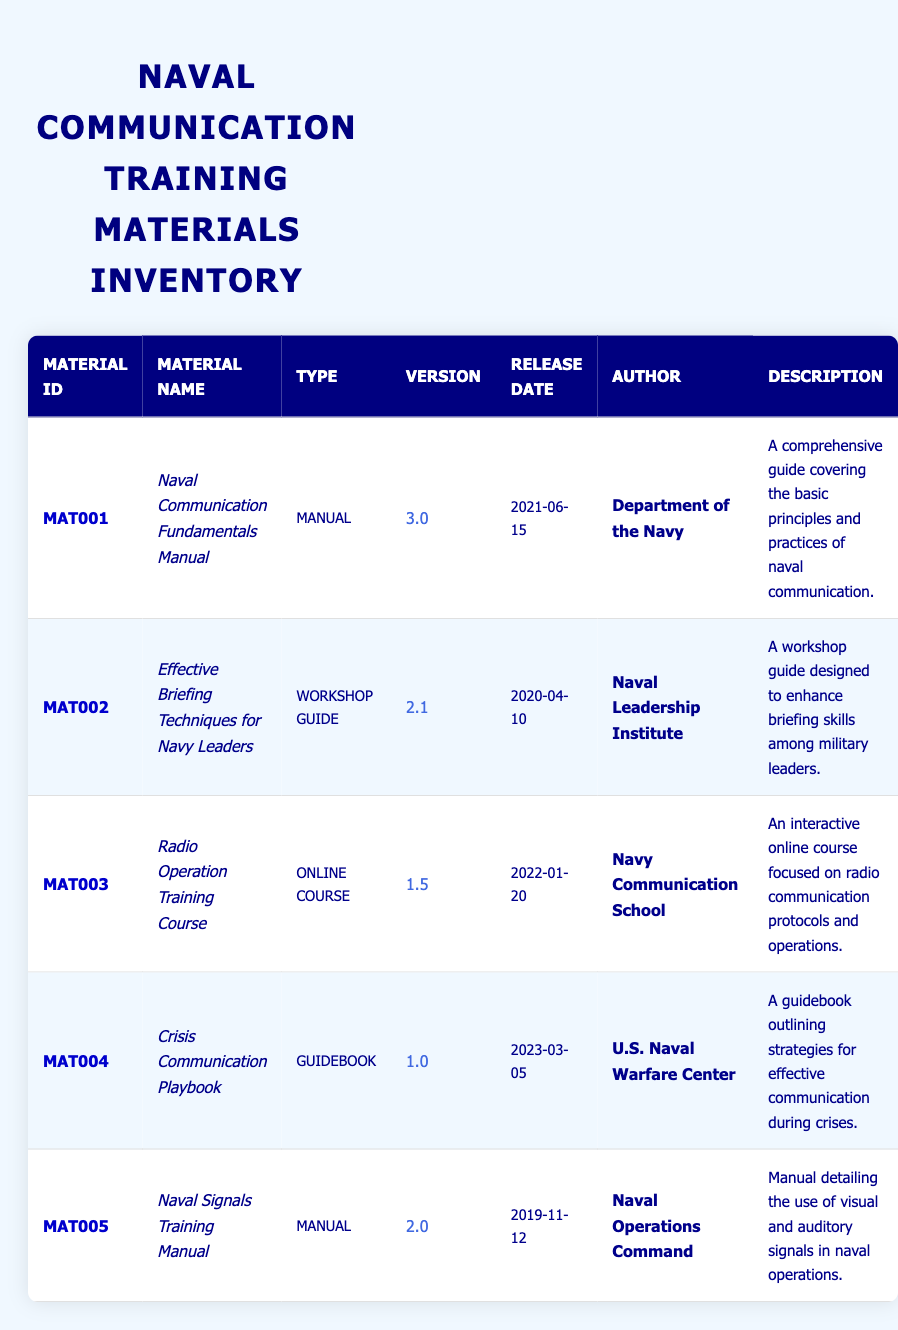What is the title of the manual with material ID MAT001? By looking at the inventory table, we see that for the material ID MAT001, the corresponding material name is "Naval Communication Fundamentals Manual".
Answer: Naval Communication Fundamentals Manual Who is the author of the "Crisis Communication Playbook"? The inventory lists the author of the material titled "Crisis Communication Playbook" as "U.S. Naval Warfare Center".
Answer: U.S. Naval Warfare Center What type of training material was released most recently? Checking the release dates in the table, the "Crisis Communication Playbook" with a release date of "2023-03-05" was released most recently.
Answer: Guidebook Is the version of the "Radio Operation Training Course" greater than 1.0? The version for the "Radio Operation Training Course" is "1.5", which is greater than "1.0". So, the answer is yes.
Answer: Yes How many training materials are authored by the Department of the Navy? In the inventory, there is one entry where the author is listed as "Department of the Navy", specifically for the "Naval Communication Fundamentals Manual".
Answer: 1 What is the difference in versions between the "Effective Briefing Techniques for Navy Leaders" and the "Naval Signals Training Manual"? The version of "Effective Briefing Techniques for Navy Leaders" is "2.1", and the version of "Naval Signals Training Manual" is "2.0". The difference is 2.1 - 2.0 = 0.1.
Answer: 0.1 Which type of training material is "MAT002"? Looking at the table, we can see that "MAT002" is categorized as a "Workshop Guide".
Answer: Workshop Guide Is the "Radio Operation Training Course" the only online training material listed? Upon review of the table, "Radio Operation Training Course" is the only entry categorized as an "Online Course", confirming it is indeed the only one.
Answer: Yes What training materials were published before 2021? By examining the release dates, the materials "Effective Briefing Techniques for Navy Leaders" (2020-04-10) and "Naval Signals Training Manual" (2019-11-12) were both released before 2021.
Answer: 2 